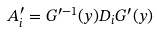<formula> <loc_0><loc_0><loc_500><loc_500>A _ { i } ^ { \prime } = G ^ { \prime - 1 } ( y ) D _ { i } G ^ { \prime } ( y )</formula> 